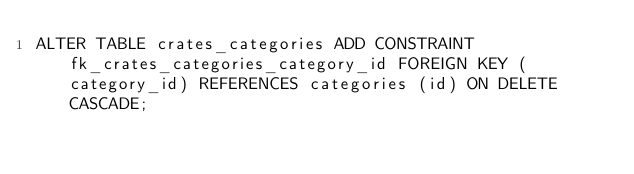Convert code to text. <code><loc_0><loc_0><loc_500><loc_500><_SQL_>ALTER TABLE crates_categories ADD CONSTRAINT fk_crates_categories_category_id FOREIGN KEY (category_id) REFERENCES categories (id) ON DELETE CASCADE;</code> 